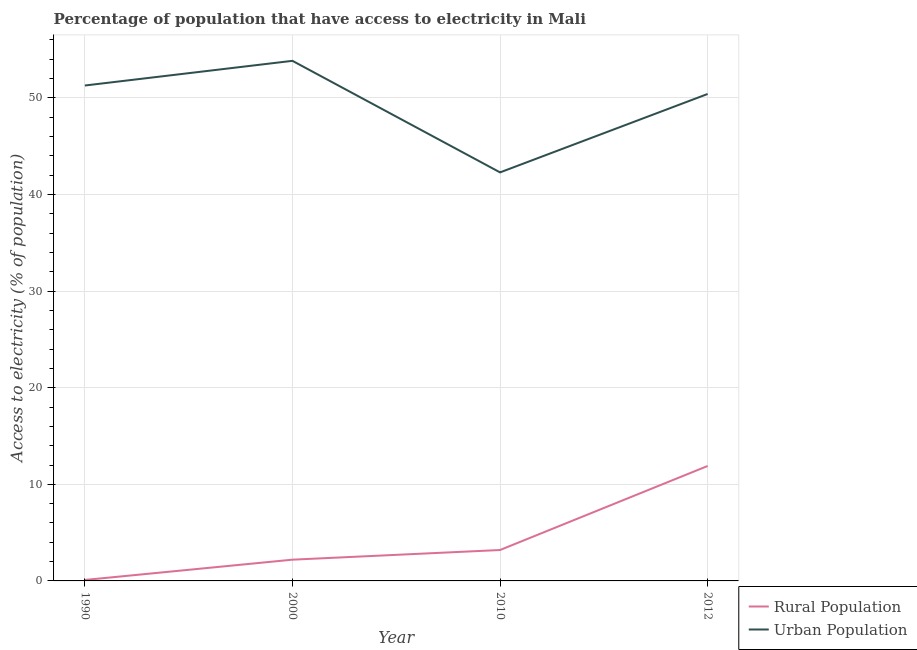How many different coloured lines are there?
Provide a succinct answer. 2. Does the line corresponding to percentage of urban population having access to electricity intersect with the line corresponding to percentage of rural population having access to electricity?
Offer a very short reply. No. What is the percentage of urban population having access to electricity in 2012?
Provide a succinct answer. 50.41. Across all years, what is the maximum percentage of urban population having access to electricity?
Make the answer very short. 53.84. Across all years, what is the minimum percentage of urban population having access to electricity?
Provide a succinct answer. 42.29. In which year was the percentage of rural population having access to electricity maximum?
Offer a very short reply. 2012. In which year was the percentage of urban population having access to electricity minimum?
Provide a short and direct response. 2010. What is the total percentage of urban population having access to electricity in the graph?
Keep it short and to the point. 197.83. What is the difference between the percentage of rural population having access to electricity in 1990 and that in 2010?
Make the answer very short. -3.1. What is the difference between the percentage of rural population having access to electricity in 1990 and the percentage of urban population having access to electricity in 2012?
Keep it short and to the point. -50.31. What is the average percentage of urban population having access to electricity per year?
Offer a terse response. 49.46. In the year 2012, what is the difference between the percentage of rural population having access to electricity and percentage of urban population having access to electricity?
Your answer should be very brief. -38.51. In how many years, is the percentage of urban population having access to electricity greater than 40 %?
Make the answer very short. 4. What is the ratio of the percentage of urban population having access to electricity in 2000 to that in 2012?
Your response must be concise. 1.07. What is the difference between the highest and the second highest percentage of rural population having access to electricity?
Your answer should be compact. 8.7. What is the difference between the highest and the lowest percentage of urban population having access to electricity?
Your answer should be compact. 11.55. In how many years, is the percentage of urban population having access to electricity greater than the average percentage of urban population having access to electricity taken over all years?
Provide a short and direct response. 3. Does the percentage of rural population having access to electricity monotonically increase over the years?
Offer a very short reply. Yes. How many lines are there?
Offer a terse response. 2. How many years are there in the graph?
Ensure brevity in your answer.  4. Does the graph contain grids?
Your answer should be compact. Yes. How many legend labels are there?
Give a very brief answer. 2. How are the legend labels stacked?
Make the answer very short. Vertical. What is the title of the graph?
Your answer should be very brief. Percentage of population that have access to electricity in Mali. Does "IMF concessional" appear as one of the legend labels in the graph?
Give a very brief answer. No. What is the label or title of the X-axis?
Your response must be concise. Year. What is the label or title of the Y-axis?
Provide a short and direct response. Access to electricity (% of population). What is the Access to electricity (% of population) in Urban Population in 1990?
Offer a very short reply. 51.29. What is the Access to electricity (% of population) of Urban Population in 2000?
Your answer should be compact. 53.84. What is the Access to electricity (% of population) in Urban Population in 2010?
Keep it short and to the point. 42.29. What is the Access to electricity (% of population) in Rural Population in 2012?
Keep it short and to the point. 11.9. What is the Access to electricity (% of population) of Urban Population in 2012?
Your answer should be compact. 50.41. Across all years, what is the maximum Access to electricity (% of population) in Urban Population?
Your answer should be compact. 53.84. Across all years, what is the minimum Access to electricity (% of population) in Rural Population?
Offer a very short reply. 0.1. Across all years, what is the minimum Access to electricity (% of population) of Urban Population?
Your response must be concise. 42.29. What is the total Access to electricity (% of population) in Urban Population in the graph?
Provide a succinct answer. 197.83. What is the difference between the Access to electricity (% of population) of Urban Population in 1990 and that in 2000?
Offer a very short reply. -2.56. What is the difference between the Access to electricity (% of population) of Urban Population in 1990 and that in 2010?
Give a very brief answer. 8.99. What is the difference between the Access to electricity (% of population) in Rural Population in 1990 and that in 2012?
Provide a short and direct response. -11.8. What is the difference between the Access to electricity (% of population) in Urban Population in 1990 and that in 2012?
Ensure brevity in your answer.  0.88. What is the difference between the Access to electricity (% of population) in Urban Population in 2000 and that in 2010?
Your response must be concise. 11.55. What is the difference between the Access to electricity (% of population) of Urban Population in 2000 and that in 2012?
Offer a terse response. 3.43. What is the difference between the Access to electricity (% of population) in Rural Population in 2010 and that in 2012?
Your answer should be very brief. -8.7. What is the difference between the Access to electricity (% of population) of Urban Population in 2010 and that in 2012?
Offer a very short reply. -8.12. What is the difference between the Access to electricity (% of population) of Rural Population in 1990 and the Access to electricity (% of population) of Urban Population in 2000?
Give a very brief answer. -53.74. What is the difference between the Access to electricity (% of population) of Rural Population in 1990 and the Access to electricity (% of population) of Urban Population in 2010?
Offer a terse response. -42.19. What is the difference between the Access to electricity (% of population) of Rural Population in 1990 and the Access to electricity (% of population) of Urban Population in 2012?
Your answer should be very brief. -50.31. What is the difference between the Access to electricity (% of population) in Rural Population in 2000 and the Access to electricity (% of population) in Urban Population in 2010?
Your answer should be very brief. -40.09. What is the difference between the Access to electricity (% of population) in Rural Population in 2000 and the Access to electricity (% of population) in Urban Population in 2012?
Ensure brevity in your answer.  -48.21. What is the difference between the Access to electricity (% of population) of Rural Population in 2010 and the Access to electricity (% of population) of Urban Population in 2012?
Provide a short and direct response. -47.21. What is the average Access to electricity (% of population) of Rural Population per year?
Keep it short and to the point. 4.35. What is the average Access to electricity (% of population) of Urban Population per year?
Your response must be concise. 49.46. In the year 1990, what is the difference between the Access to electricity (% of population) in Rural Population and Access to electricity (% of population) in Urban Population?
Offer a terse response. -51.19. In the year 2000, what is the difference between the Access to electricity (% of population) of Rural Population and Access to electricity (% of population) of Urban Population?
Your answer should be compact. -51.64. In the year 2010, what is the difference between the Access to electricity (% of population) of Rural Population and Access to electricity (% of population) of Urban Population?
Provide a succinct answer. -39.09. In the year 2012, what is the difference between the Access to electricity (% of population) in Rural Population and Access to electricity (% of population) in Urban Population?
Your answer should be compact. -38.51. What is the ratio of the Access to electricity (% of population) of Rural Population in 1990 to that in 2000?
Ensure brevity in your answer.  0.05. What is the ratio of the Access to electricity (% of population) of Urban Population in 1990 to that in 2000?
Provide a succinct answer. 0.95. What is the ratio of the Access to electricity (% of population) of Rural Population in 1990 to that in 2010?
Your response must be concise. 0.03. What is the ratio of the Access to electricity (% of population) in Urban Population in 1990 to that in 2010?
Your answer should be very brief. 1.21. What is the ratio of the Access to electricity (% of population) of Rural Population in 1990 to that in 2012?
Your response must be concise. 0.01. What is the ratio of the Access to electricity (% of population) in Urban Population in 1990 to that in 2012?
Offer a very short reply. 1.02. What is the ratio of the Access to electricity (% of population) of Rural Population in 2000 to that in 2010?
Give a very brief answer. 0.69. What is the ratio of the Access to electricity (% of population) of Urban Population in 2000 to that in 2010?
Keep it short and to the point. 1.27. What is the ratio of the Access to electricity (% of population) of Rural Population in 2000 to that in 2012?
Your response must be concise. 0.18. What is the ratio of the Access to electricity (% of population) of Urban Population in 2000 to that in 2012?
Offer a terse response. 1.07. What is the ratio of the Access to electricity (% of population) in Rural Population in 2010 to that in 2012?
Offer a very short reply. 0.27. What is the ratio of the Access to electricity (% of population) in Urban Population in 2010 to that in 2012?
Give a very brief answer. 0.84. What is the difference between the highest and the second highest Access to electricity (% of population) of Urban Population?
Your response must be concise. 2.56. What is the difference between the highest and the lowest Access to electricity (% of population) in Rural Population?
Your response must be concise. 11.8. What is the difference between the highest and the lowest Access to electricity (% of population) of Urban Population?
Your answer should be very brief. 11.55. 